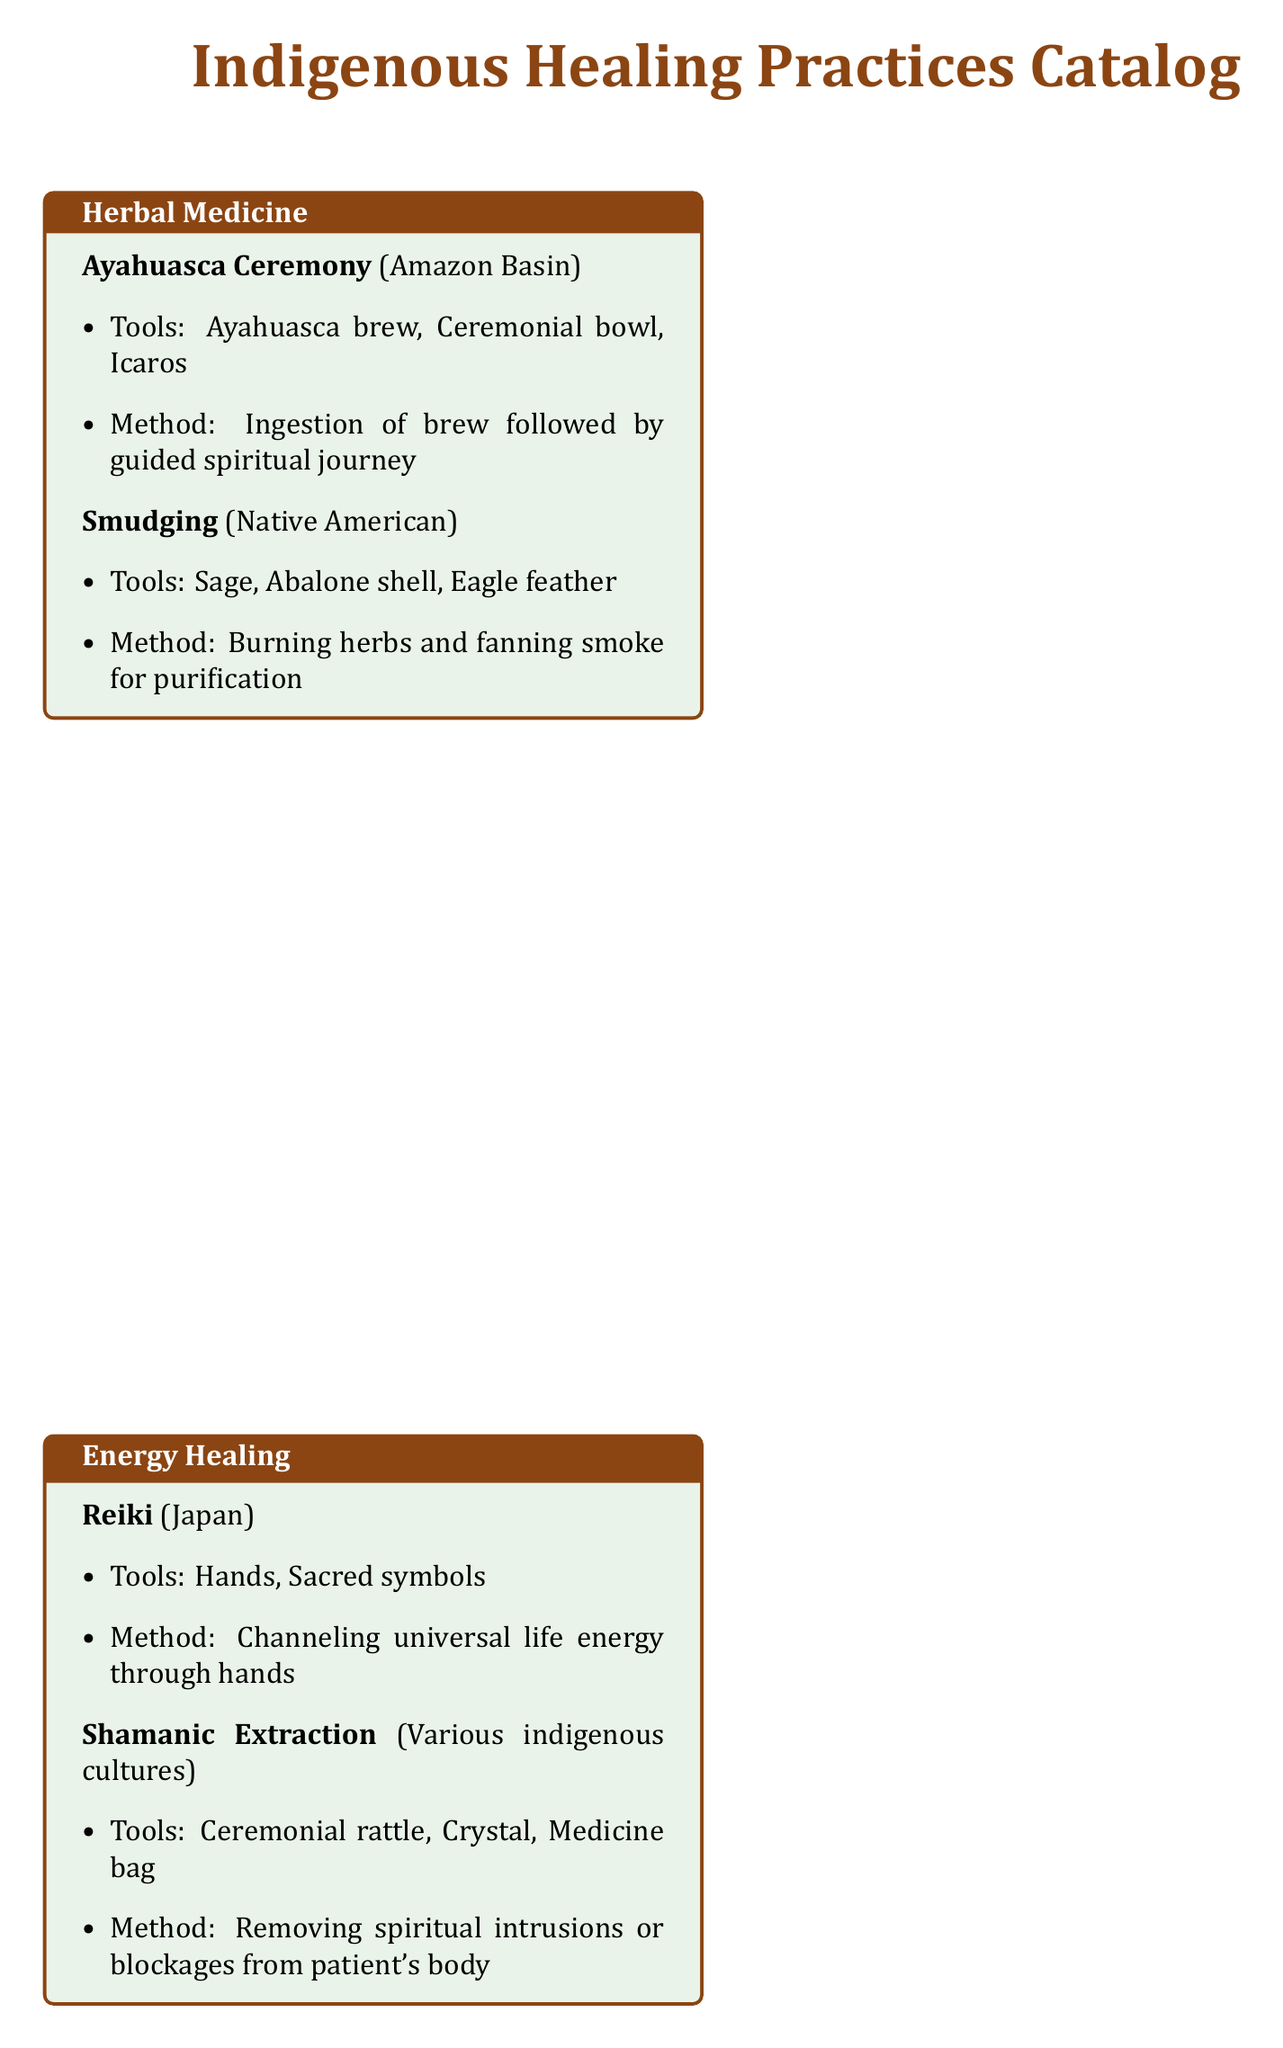What is the first practice listed under Herbal Medicine? The first practice listed under Herbal Medicine is "Ayahuasca Ceremony."
Answer: Ayahuasca Ceremony What tools are used in the Temazcal Ceremony? The tools used in the Temazcal Ceremony are "Sweat lodge, Heated stones, Herbal infusions."
Answer: Sweat lodge, Heated stones, Herbal infusions Which indigenous healer specializes in ancestral communication? The indigenous healer that specializes in ancestral communication is the "Sangoma."
Answer: Sangoma What is the method used in the Soul Retrieval practice? The method used in the Soul Retrieval practice is "Shamanic journey to recover lost soul parts."
Answer: Shamanic journey to recover lost soul parts How many practices are listed under Energy Healing? There are two practices listed under Energy Healing: "Reiki" and "Shamanic Extraction."
Answer: 2 What is the origin of the energy healing practice Reiki? The origin of the energy healing practice Reiki is "Japan."
Answer: Japan What is the primary tool for the Ayahuasca Ceremony? The primary tool for the Ayahuasca Ceremony is "Ayahuasca brew."
Answer: Ayahuasca brew Which healer is associated with ceremonial healing? The healer associated with ceremonial healing is the "Medicine Man/Woman."
Answer: Medicine Man/Woman 